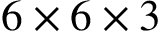<formula> <loc_0><loc_0><loc_500><loc_500>6 \times 6 \times 3</formula> 